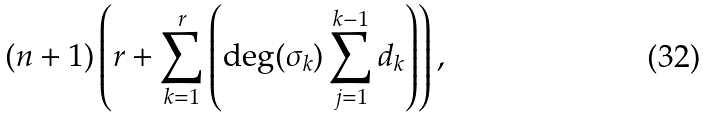Convert formula to latex. <formula><loc_0><loc_0><loc_500><loc_500>( n + 1 ) \left ( r + \sum _ { k = 1 } ^ { r } \left ( \deg ( \sigma _ { k } ) \sum _ { j = 1 } ^ { k - 1 } d _ { k } \right ) \right ) ,</formula> 